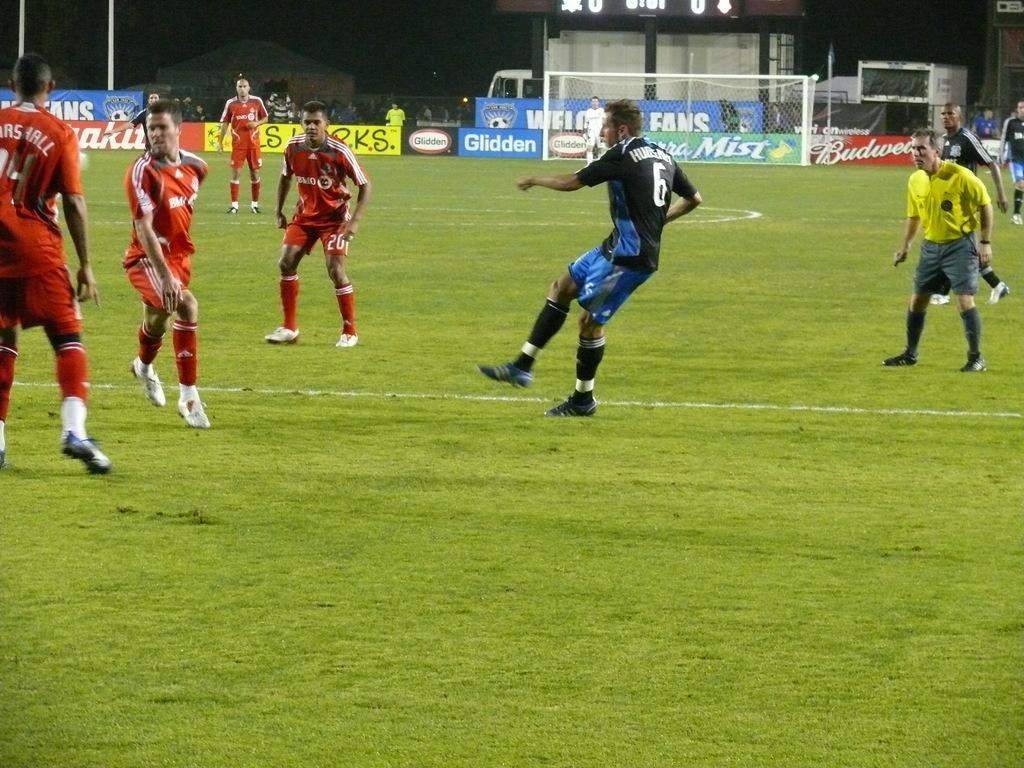Describe this image in one or two sentences. In this picture there are few persons wearing red and black color dress are standing on a greenery ground and there is a referee wearing yellow T-shirt in the right corner and there is a net and some other objects in the background. 